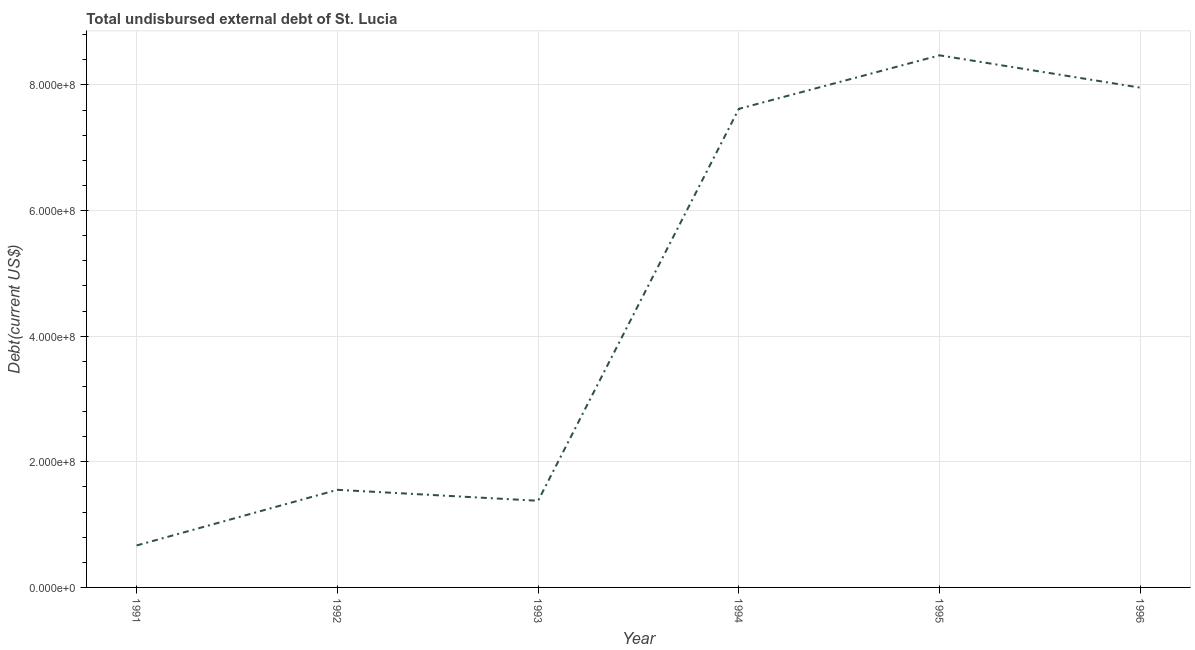What is the total debt in 1993?
Your response must be concise. 1.38e+08. Across all years, what is the maximum total debt?
Provide a short and direct response. 8.47e+08. Across all years, what is the minimum total debt?
Provide a short and direct response. 6.68e+07. In which year was the total debt maximum?
Your answer should be very brief. 1995. What is the sum of the total debt?
Your answer should be compact. 2.77e+09. What is the difference between the total debt in 1993 and 1995?
Make the answer very short. -7.09e+08. What is the average total debt per year?
Offer a terse response. 4.61e+08. What is the median total debt?
Keep it short and to the point. 4.59e+08. Do a majority of the years between 1992 and 1991 (inclusive) have total debt greater than 480000000 US$?
Ensure brevity in your answer.  No. What is the ratio of the total debt in 1991 to that in 1992?
Ensure brevity in your answer.  0.43. Is the total debt in 1992 less than that in 1993?
Provide a short and direct response. No. Is the difference between the total debt in 1995 and 1996 greater than the difference between any two years?
Your answer should be compact. No. What is the difference between the highest and the second highest total debt?
Offer a very short reply. 5.15e+07. What is the difference between the highest and the lowest total debt?
Make the answer very short. 7.80e+08. In how many years, is the total debt greater than the average total debt taken over all years?
Offer a terse response. 3. How many lines are there?
Provide a short and direct response. 1. How many years are there in the graph?
Provide a short and direct response. 6. Does the graph contain any zero values?
Your answer should be very brief. No. What is the title of the graph?
Your response must be concise. Total undisbursed external debt of St. Lucia. What is the label or title of the Y-axis?
Keep it short and to the point. Debt(current US$). What is the Debt(current US$) in 1991?
Keep it short and to the point. 6.68e+07. What is the Debt(current US$) of 1992?
Your response must be concise. 1.55e+08. What is the Debt(current US$) of 1993?
Your answer should be compact. 1.38e+08. What is the Debt(current US$) of 1994?
Make the answer very short. 7.62e+08. What is the Debt(current US$) in 1995?
Make the answer very short. 8.47e+08. What is the Debt(current US$) of 1996?
Your answer should be very brief. 7.96e+08. What is the difference between the Debt(current US$) in 1991 and 1992?
Make the answer very short. -8.86e+07. What is the difference between the Debt(current US$) in 1991 and 1993?
Your answer should be very brief. -7.11e+07. What is the difference between the Debt(current US$) in 1991 and 1994?
Offer a terse response. -6.95e+08. What is the difference between the Debt(current US$) in 1991 and 1995?
Provide a succinct answer. -7.80e+08. What is the difference between the Debt(current US$) in 1991 and 1996?
Offer a terse response. -7.29e+08. What is the difference between the Debt(current US$) in 1992 and 1993?
Make the answer very short. 1.75e+07. What is the difference between the Debt(current US$) in 1992 and 1994?
Provide a short and direct response. -6.07e+08. What is the difference between the Debt(current US$) in 1992 and 1995?
Your answer should be compact. -6.92e+08. What is the difference between the Debt(current US$) in 1992 and 1996?
Your response must be concise. -6.40e+08. What is the difference between the Debt(current US$) in 1993 and 1994?
Provide a short and direct response. -6.24e+08. What is the difference between the Debt(current US$) in 1993 and 1995?
Give a very brief answer. -7.09e+08. What is the difference between the Debt(current US$) in 1993 and 1996?
Your answer should be compact. -6.58e+08. What is the difference between the Debt(current US$) in 1994 and 1995?
Your answer should be compact. -8.52e+07. What is the difference between the Debt(current US$) in 1994 and 1996?
Offer a terse response. -3.37e+07. What is the difference between the Debt(current US$) in 1995 and 1996?
Provide a short and direct response. 5.15e+07. What is the ratio of the Debt(current US$) in 1991 to that in 1992?
Offer a very short reply. 0.43. What is the ratio of the Debt(current US$) in 1991 to that in 1993?
Provide a succinct answer. 0.48. What is the ratio of the Debt(current US$) in 1991 to that in 1994?
Offer a terse response. 0.09. What is the ratio of the Debt(current US$) in 1991 to that in 1995?
Your response must be concise. 0.08. What is the ratio of the Debt(current US$) in 1991 to that in 1996?
Offer a very short reply. 0.08. What is the ratio of the Debt(current US$) in 1992 to that in 1993?
Ensure brevity in your answer.  1.13. What is the ratio of the Debt(current US$) in 1992 to that in 1994?
Offer a very short reply. 0.2. What is the ratio of the Debt(current US$) in 1992 to that in 1995?
Your response must be concise. 0.18. What is the ratio of the Debt(current US$) in 1992 to that in 1996?
Ensure brevity in your answer.  0.2. What is the ratio of the Debt(current US$) in 1993 to that in 1994?
Your answer should be compact. 0.18. What is the ratio of the Debt(current US$) in 1993 to that in 1995?
Provide a succinct answer. 0.16. What is the ratio of the Debt(current US$) in 1993 to that in 1996?
Offer a very short reply. 0.17. What is the ratio of the Debt(current US$) in 1994 to that in 1995?
Keep it short and to the point. 0.9. What is the ratio of the Debt(current US$) in 1994 to that in 1996?
Your response must be concise. 0.96. What is the ratio of the Debt(current US$) in 1995 to that in 1996?
Ensure brevity in your answer.  1.06. 